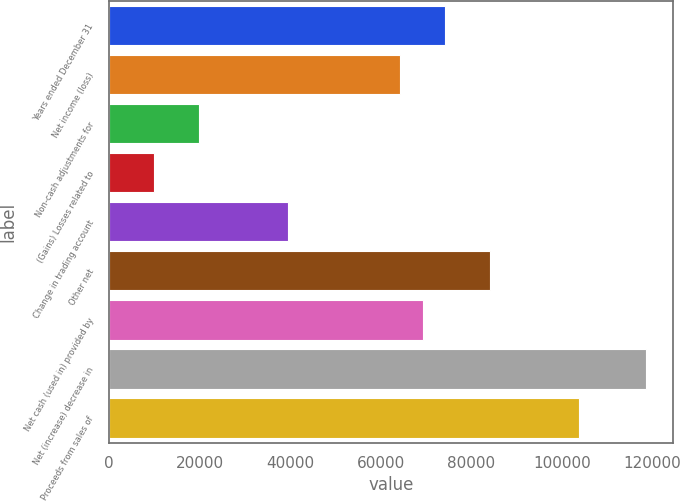<chart> <loc_0><loc_0><loc_500><loc_500><bar_chart><fcel>Years ended December 31<fcel>Net income (loss)<fcel>Non-cash adjustments for<fcel>(Gains) Losses related to<fcel>Change in trading account<fcel>Other net<fcel>Net cash (used in) provided by<fcel>Net (increase) decrease in<fcel>Proceeds from sales of<nl><fcel>74171<fcel>64287.4<fcel>19811.2<fcel>9927.6<fcel>39578.4<fcel>84054.6<fcel>69229.2<fcel>118647<fcel>103822<nl></chart> 